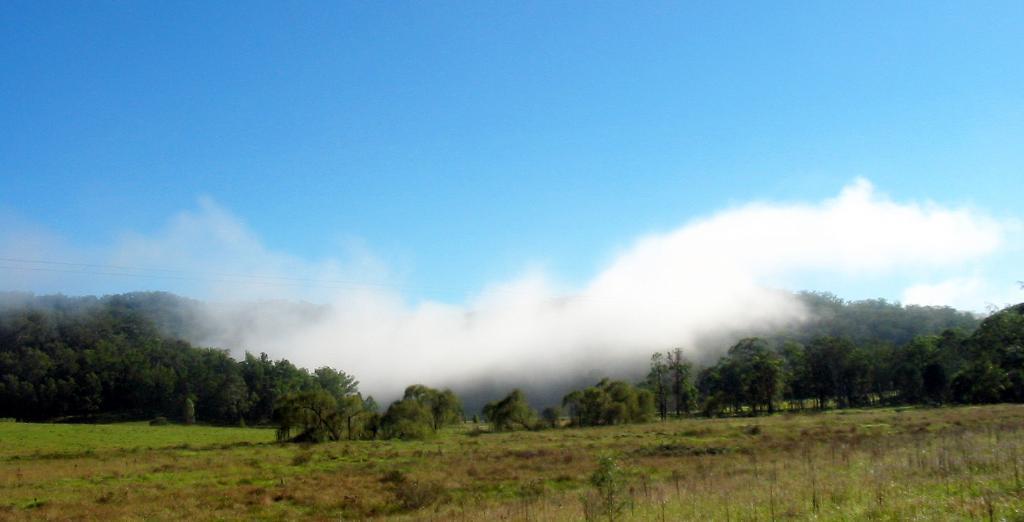How would you summarize this image in a sentence or two? These are the trees. This looks like a fog. I can see the grass and plants. This is the sky. 